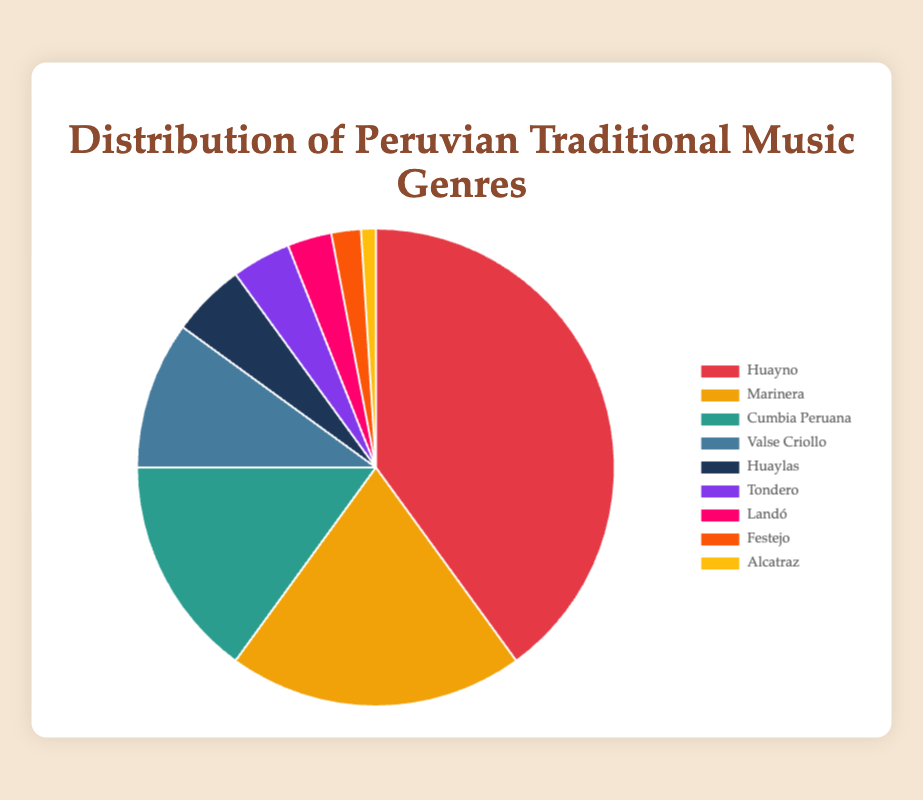Which genre has the highest percentage? Look at the pie chart and identify the genre with the largest slice. The largest slice corresponds to Huayno.
Answer: Huayno Which two genres together make up 35% of the distribution? Identify two genres whose percentages together equal 35%. "Cumbia Peruana" (15%) and "Valse Criollo" (10%) together make up 25%, so no, check others, "Marinera" (20%) and "Cumbia Peruana" (15%) together make up 35%.
Answer: Marinera and Cumbia Peruana What percentage of the chart is made up of genres with at least 10%? Identify all genres with percentages of at least 10% (Huayno, Marinera, Cumbia Peruana, and Valse Criollo), and add their percentages together (40 + 20 + 15 + 10).
Answer: 85% Which genre has a larger slice: Tondero or Festejo? Compare the percentages of Tondero and Festejo. Tondero has 4%, while Festejo has 2%, so Tondero has a larger slice.
Answer: Tondero How much larger is Huayno's slice compared to Marinera's slice? Subtract Marinera's percentage from Huayno's percentage (40 - 20).
Answer: 20% What's the total percentage for the genres that have less than 3%? Identify genres with less than 3% (Landó, Festejo, and Alcatraz) and sum their percentages (3 + 2 + 1).
Answer: 6% Which genre has the smallest slice, and what percentage is it? Look at the pie chart and identify the genre with the smallest slice. It is Alcatraz with 1%.
Answer: Alcatraz, 1% How does the percentage of Valse Criollo compare to that of Huaylas? Compare the percentages: Valse Criollo has 10% and Huaylas has 5%, so Valse Criollo is larger.
Answer: Valse Criollo is larger What is the combined percentage of Huayno, Marinera, and Cumbia Peruana? Sum the percentages of Huayno, Marinera, and Cumbia Peruana (40 + 20 + 15).
Answer: 75% 